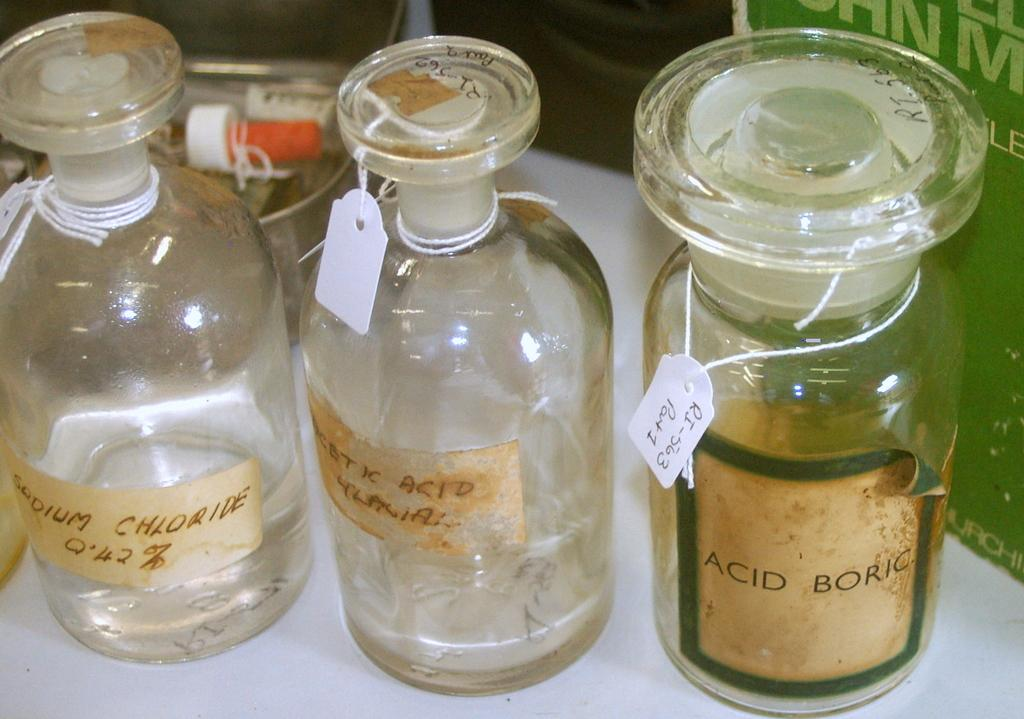<image>
Describe the image concisely. Three glass bottles are next to each other, one labeled Acid Boric. 